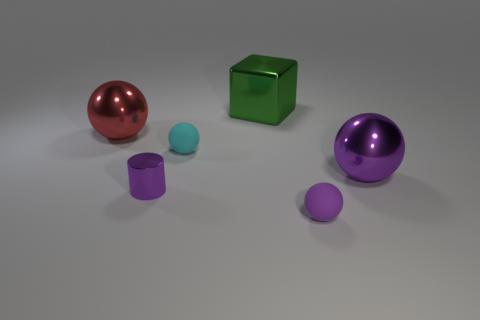Subtract all large red balls. How many balls are left? 3 Subtract all yellow cylinders. How many purple spheres are left? 2 Add 1 cyan matte cubes. How many objects exist? 7 Subtract 1 cylinders. How many cylinders are left? 0 Subtract all cyan balls. How many balls are left? 3 Subtract all cylinders. How many objects are left? 5 Add 3 tiny purple metal objects. How many tiny purple metal objects exist? 4 Subtract 0 purple blocks. How many objects are left? 6 Subtract all blue cylinders. Subtract all red blocks. How many cylinders are left? 1 Subtract all large purple shiny spheres. Subtract all big green things. How many objects are left? 4 